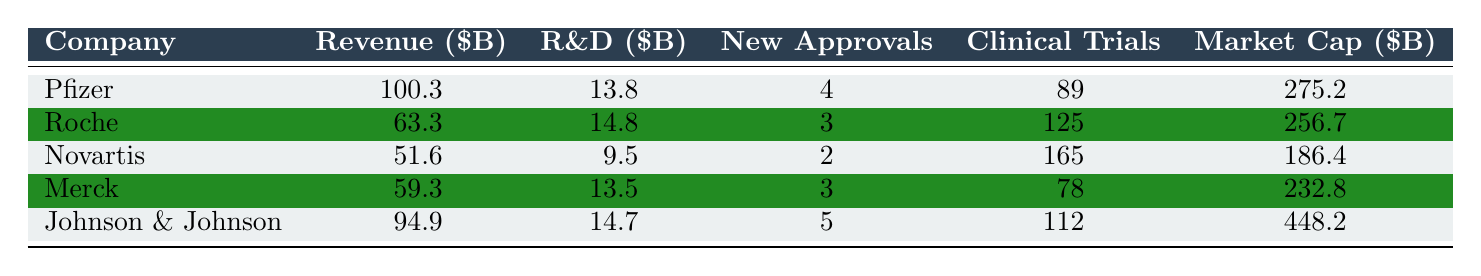What is the revenue of Pfizer? According to the table, Pfizer's revenue is listed as 100.3 billion USD.
Answer: 100.3 billion USD Which company has the highest R&D expenses? The table shows that Johnson & Johnson has R&D expenses of 14.7 billion USD, which is higher than any other company listed.
Answer: Johnson & Johnson How many new drug approvals did Novartis receive? The table indicates that Novartis received 2 new drug approvals in 2022.
Answer: 2 What is the difference in market capitalization between Merck and Roche? The market cap for Merck is 232.8 billion USD and for Roche it is 256.7 billion USD. The difference is 256.7 - 232.8 = 23.9 billion USD.
Answer: 23.9 billion USD Which company had the most clinical trials in progress? The table states that Novartis had 165 clinical trials in progress, which is the highest among the companies listed.
Answer: Novartis What is the average revenue of the top 5 biotech companies? The revenues are 100.3, 63.3, 51.6, 59.3, and 94.9 billion USD. Adding them gives a total of 369.4 billion USD. The average is 369.4 / 5 = 73.88 billion USD.
Answer: 73.88 billion USD Did Merck have more new drug approvals than Roche? Merck had 3 new drug approvals and Roche had 3 as well. Therefore, they have the same number of new approvals.
Answer: No Which company spent the least on R&D? According to the table, Novartis spent the least on R&D expenses, which were 9.5 billion USD, compared to the other companies.
Answer: Novartis If you combine the revenue of Pfizer and Johnson & Johnson, what is the total? Pfizer's revenue is 100.3 billion USD and Johnson & Johnson's is 94.9 billion USD. The total revenue is 100.3 + 94.9 = 195.2 billion USD.
Answer: 195.2 billion USD What percentage of the total R&D expenses is attributed to Roche? The total R&D expenses from all companies are 66.3 billion USD (13.8 + 14.8 + 9.5 + 13.5 + 14.7). Roche’s R&D expense is 14.8 billion USD. The percentage is 14.8 / 66.3 * 100 ≈ 22.3%.
Answer: 22.3% 